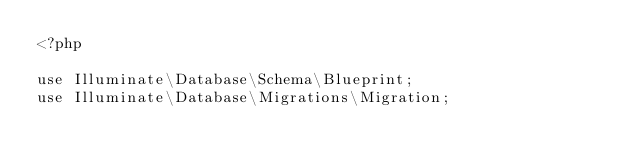Convert code to text. <code><loc_0><loc_0><loc_500><loc_500><_PHP_><?php

use Illuminate\Database\Schema\Blueprint;
use Illuminate\Database\Migrations\Migration;
</code> 